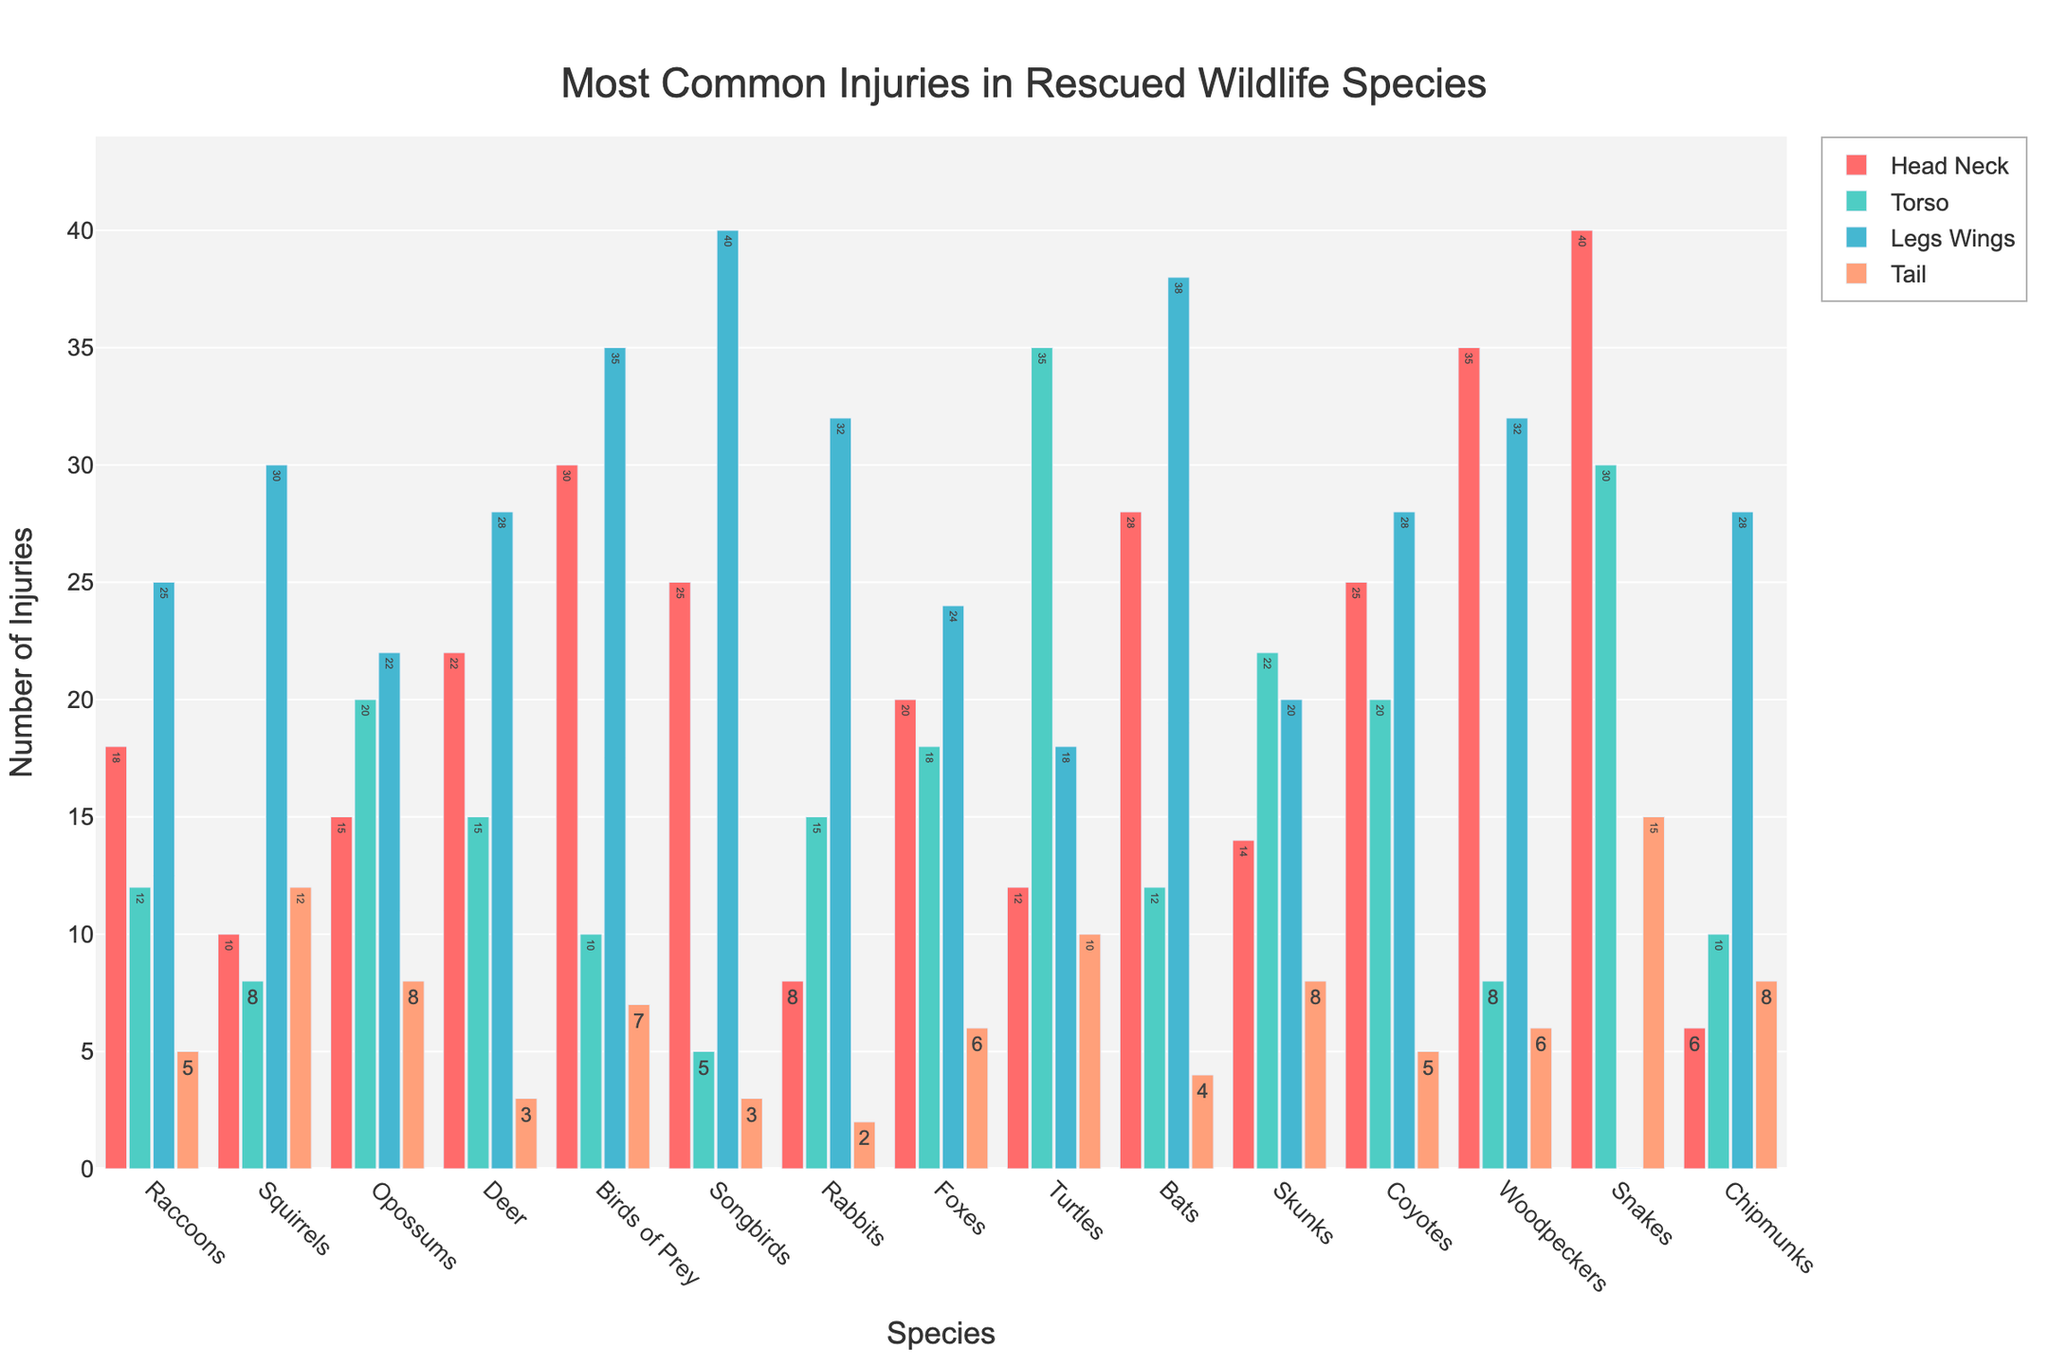Which species has the highest number of head and neck injuries? Look at the bar representing head and neck injuries for each species. The tallest bar in this category indicates the species with the highest number of injuries. In this case, it's Snakes.
Answer: Snakes Which species has the least number of torso injuries? Compare the bars representing torso injuries across all species and identify the shortest one. The shortest bar corresponds to Songbirds.
Answer: Songbirds How many total injuries do Deer have? Sum the heights of all the bars for Deer (head_neck, torso, legs_wings, tail). This is 22 + 15 + 28 + 3 = 68.
Answer: 68 What is the difference in tail injuries between Turtles and Chipmunks? Subtract the number of tail injuries for Chipmunks from that for Turtles. This is 10 - 8 = 2.
Answer: 2 Which species has more leg and wing injuries than tail injuries but fewer than torso injuries? Check each species' bars for leg and wing injuries, comparing them with the corresponding bars for tail and torso injuries. Foxes fit this criterion (24 > 6 and 24 < 18).
Answer: Foxes Which species has a total number of injuries between 80 and 100? Sum the injuries for each species and check which total falls within this range. Birds of Prey have 30 + 10 + 35 + 7 = 82 injuries, fitting this criterion.
Answer: Birds of Prey Is there any species where torso injuries are more than head and neck injuries? If yes, name one. Compare torso injuries with head and neck injuries for each species. Turtles have 35 torso injuries and 12 head and neck injuries, so they fit this criterion.
Answer: Turtles Which species has equal numbers of leg and wing injuries and torso injuries? Identify species with matching bars for leg and wing injuries and torso injuries. However, none of the species fits this condition.
Answer: None Which species has the highest number of injuries in one specific body part? Determine which species has the tallest single bar in any category. Songbirds have the tallest bar at 40 in the legs and wings category.
Answer: Songbirds Calculate the average number of head and neck injuries across all species. Add up all the head and neck injuries and divide by the number of species: (18+10+15+22+30+25+8+20+12+28+14+25+35+40+6)/15 = 278/15 ≈ 18.53.
Answer: 18.53 